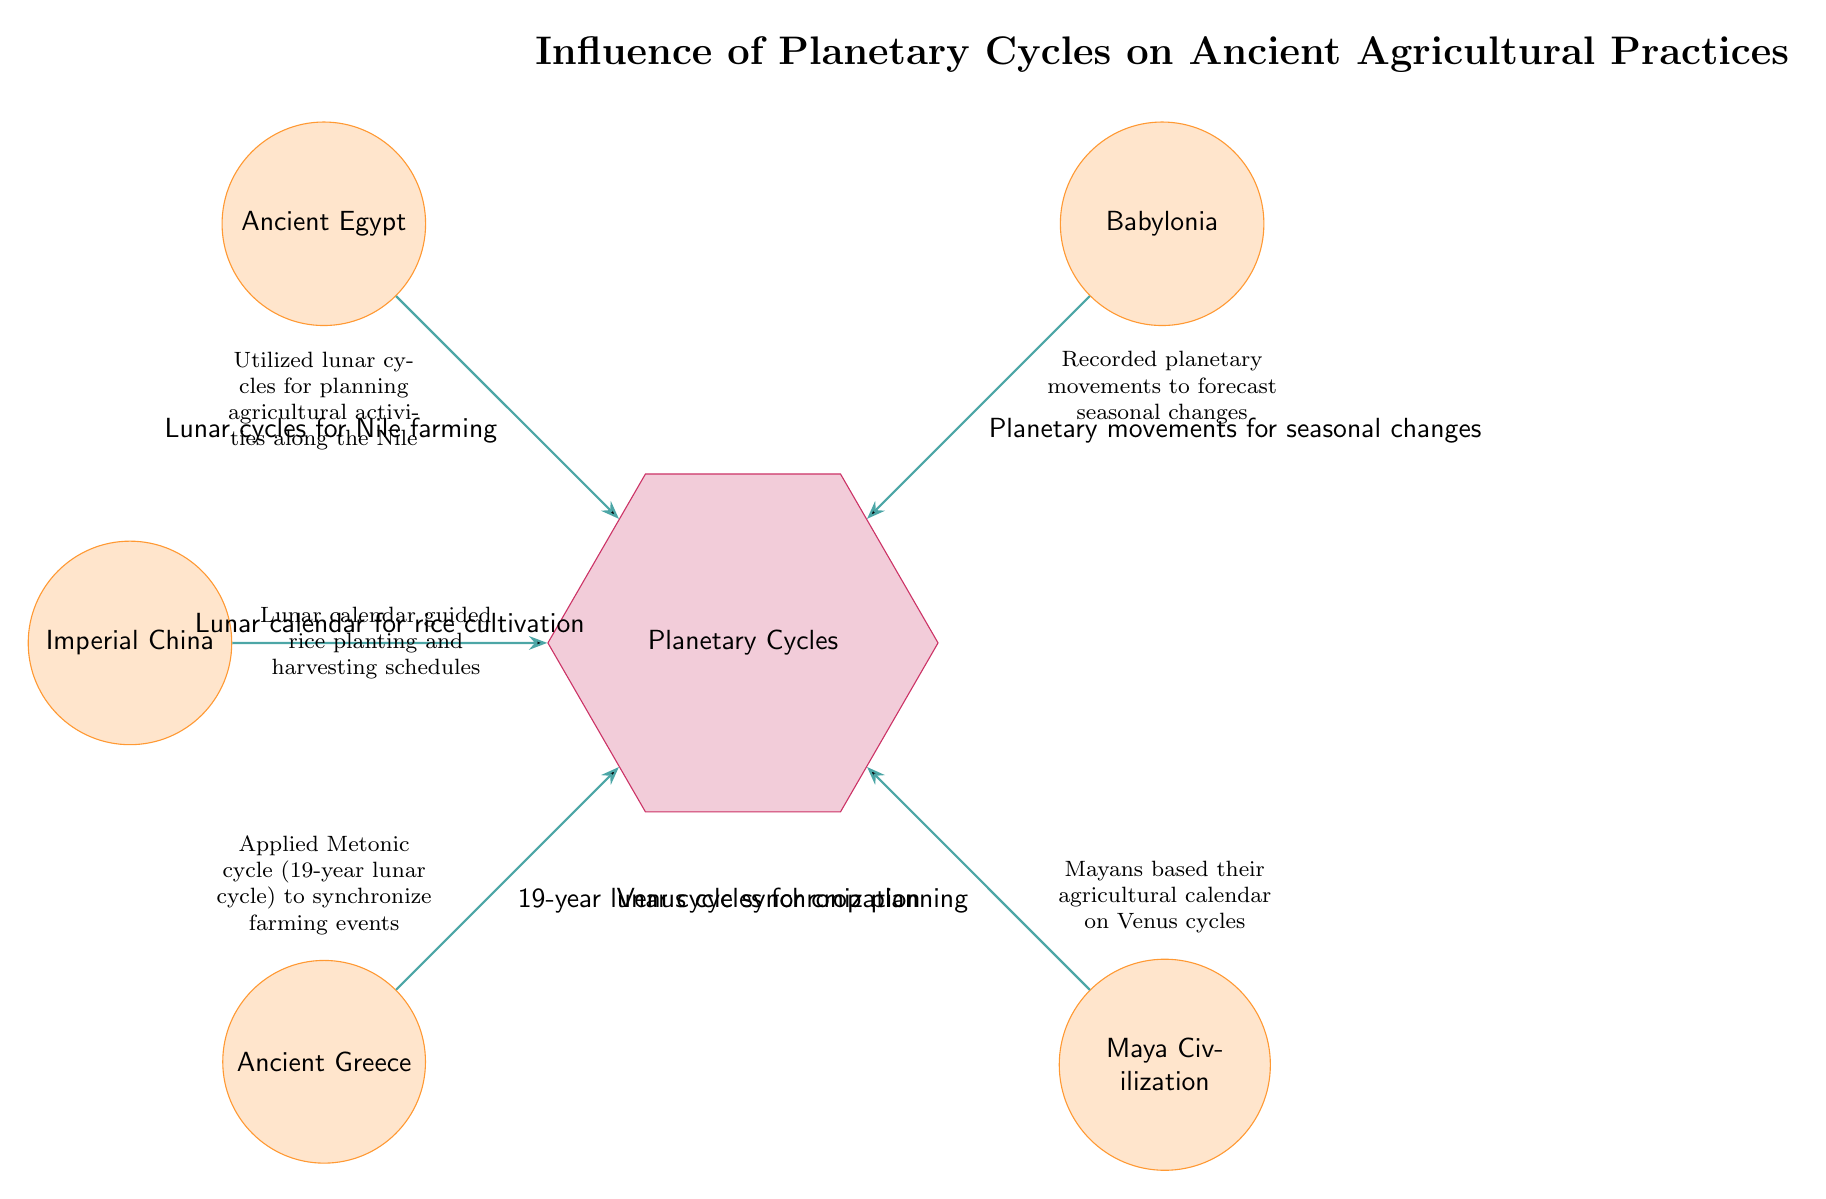What cultures are represented in the diagram? The diagram includes five cultures: Ancient Egypt, Babylonia, Maya Civilization, Ancient Greece, and Imperial China. These names are listed as nodes branching from the central theme, "Planetary Cycles."
Answer: Ancient Egypt, Babylonia, Maya Civilization, Ancient Greece, Imperial China How many main nodes are there in the diagram? The diagram consists of a total of six main nodes, one being the central node "Planetary Cycles" and five cultural nodes surrounding it. This can be counted from the visual layout.
Answer: 6 What is the agricultural practice associated with Ancient Egypt? According to the diagram, Ancient Egypt utilized lunar cycles for planning agricultural activities along the Nile, as indicated by the connection to the central node with this description below it.
Answer: Lunar cycles for Nile farming Which planetary cycle did the Maya Civilization base their agricultural calendar on? The diagram states that the Maya Civilization based their agricultural calendar on Venus cycles, which connects directly to the central theme.
Answer: Venus cycles How do the agricultural practices of Imperial China differ from those of Ancient Greece? Imperial China used a lunar calendar for rice cultivation, while Ancient Greece applied the Metonic cycle to synchronize farming events, reflected in different connections from each culture to the central node. This indicates a difference in reliance on specific lunar cycles versus a longer term synchronization cycle.
Answer: Different lunar cycle applications 